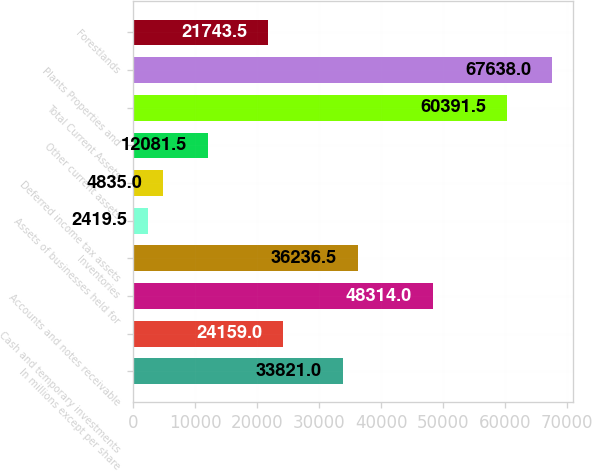Convert chart. <chart><loc_0><loc_0><loc_500><loc_500><bar_chart><fcel>In millions except per share<fcel>Cash and temporary investments<fcel>Accounts and notes receivable<fcel>Inventories<fcel>Assets of businesses held for<fcel>Deferred income tax assets<fcel>Other current assets<fcel>Total Current Assets<fcel>Plants Properties and<fcel>Forestlands<nl><fcel>33821<fcel>24159<fcel>48314<fcel>36236.5<fcel>2419.5<fcel>4835<fcel>12081.5<fcel>60391.5<fcel>67638<fcel>21743.5<nl></chart> 